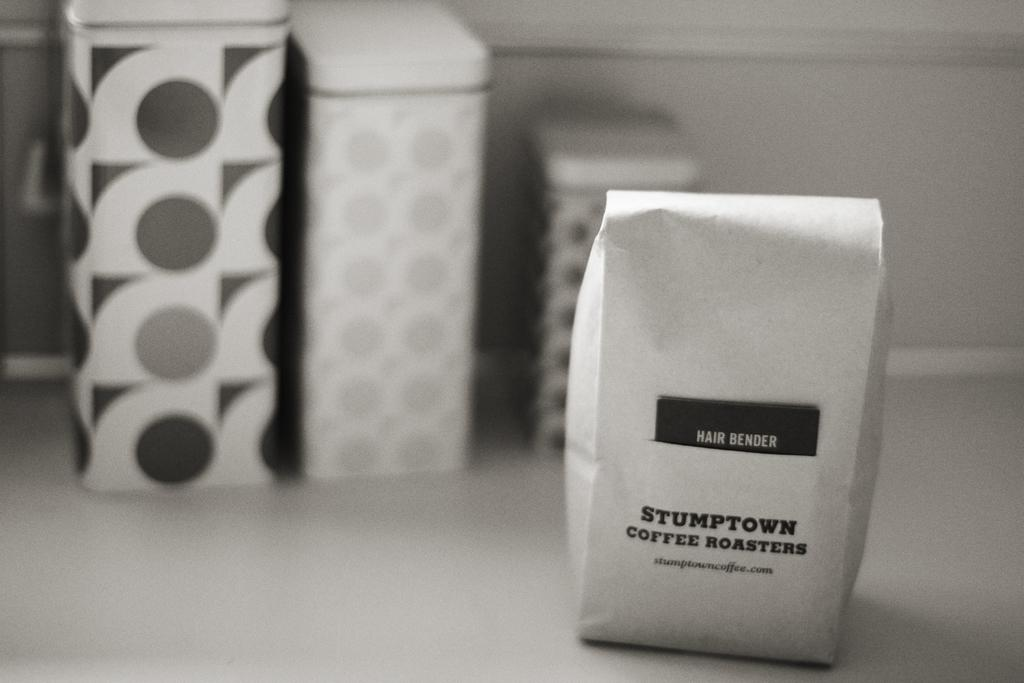<image>
Present a compact description of the photo's key features. White bag of coffee roasters from Stumptown on a table. 